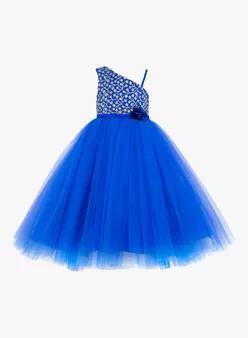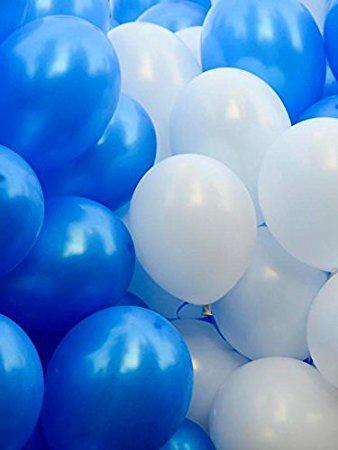The first image is the image on the left, the second image is the image on the right. Examine the images to the left and right. Is the description "the image on the right contains one round balloon on a white background" accurate? Answer yes or no. No. 